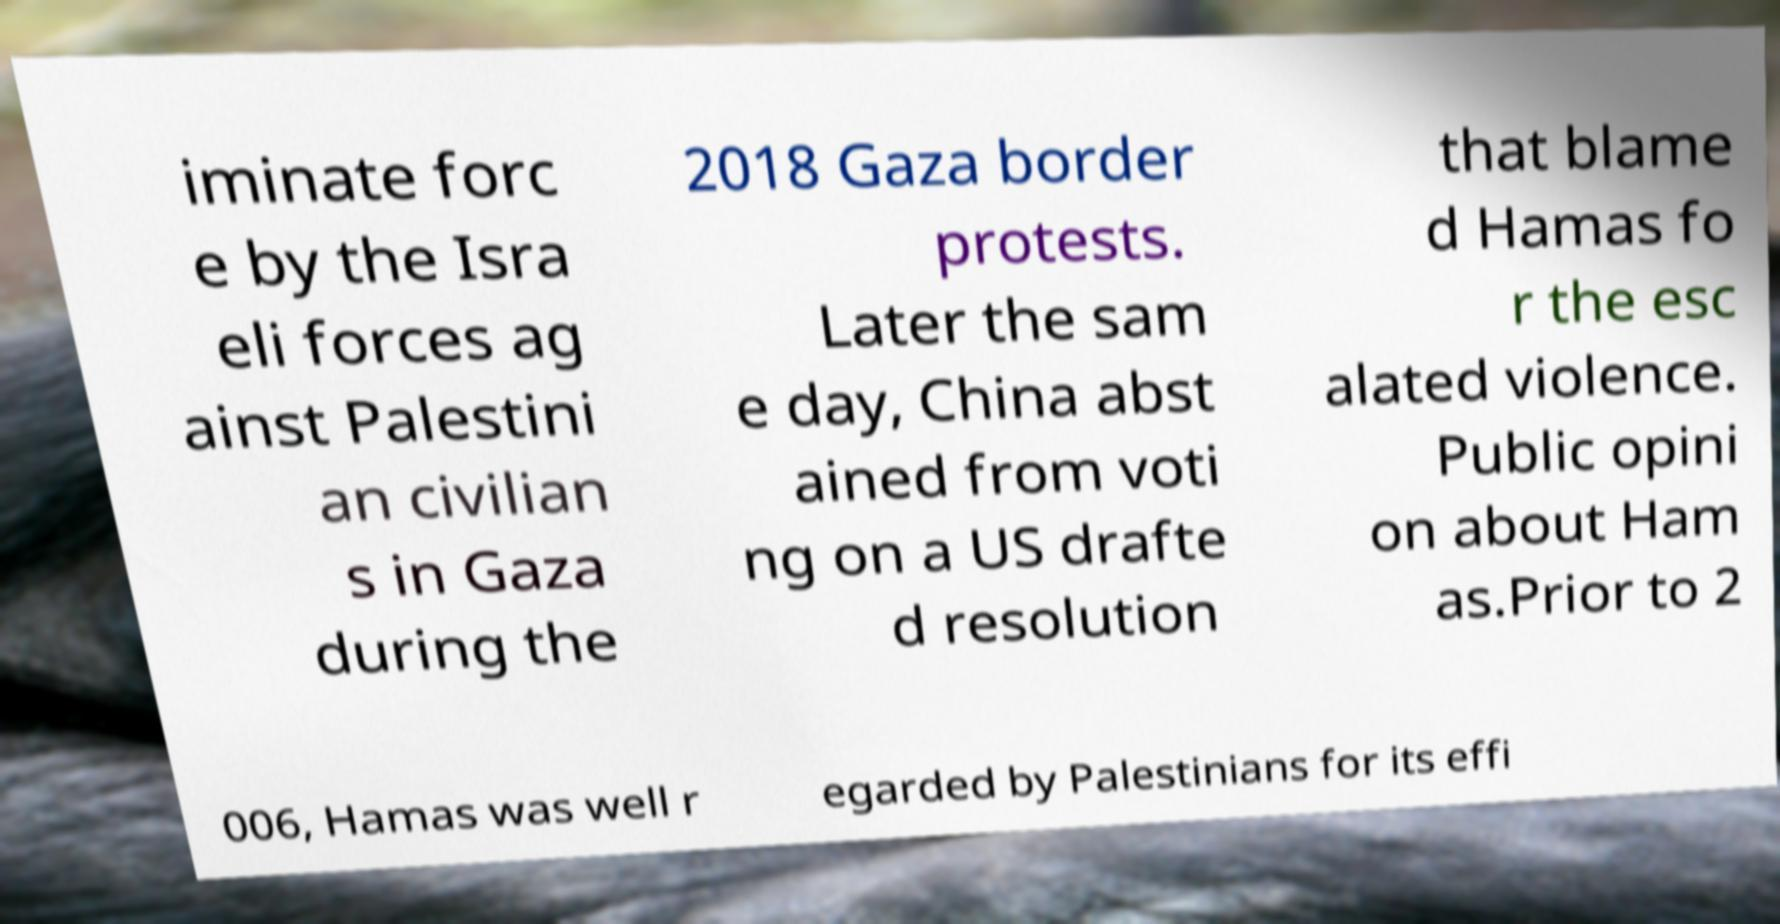What messages or text are displayed in this image? I need them in a readable, typed format. iminate forc e by the Isra eli forces ag ainst Palestini an civilian s in Gaza during the 2018 Gaza border protests. Later the sam e day, China abst ained from voti ng on a US drafte d resolution that blame d Hamas fo r the esc alated violence. Public opini on about Ham as.Prior to 2 006, Hamas was well r egarded by Palestinians for its effi 